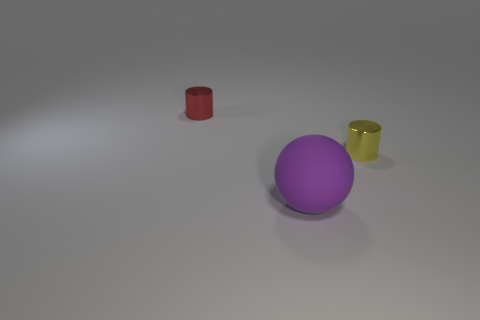There is a cylinder that is in front of the red thing; what color is it? The cylinder positioned in front of the red object is yellow in color, featuring a reflective surface that suggests it may be made of a metallic material. 